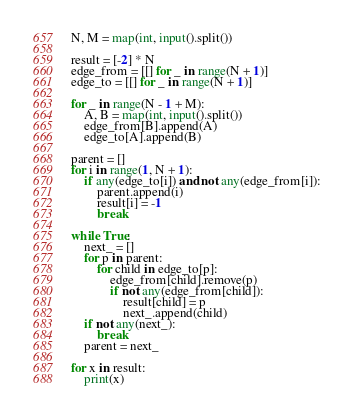Convert code to text. <code><loc_0><loc_0><loc_500><loc_500><_Python_>N, M = map(int, input().split())

result = [-2] * N
edge_from = [[] for _ in range(N + 1)]
edge_to = [[] for _ in range(N + 1)]

for _ in range(N - 1 + M):
    A, B = map(int, input().split())
    edge_from[B].append(A)
    edge_to[A].append(B)

parent = []
for i in range(1, N + 1):
    if any(edge_to[i]) and not any(edge_from[i]):
        parent.append(i)
        result[i] = -1
        break

while True:
    next_ = []
    for p in parent:
        for child in edge_to[p]:
            edge_from[child].remove(p)
            if not any(edge_from[child]):
                result[child] = p
                next_.append(child)
    if not any(next_):
        break
    parent = next_

for x in result:
    print(x)</code> 